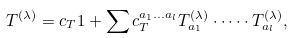<formula> <loc_0><loc_0><loc_500><loc_500>T ^ { ( \lambda ) } = c _ { T } { 1 } + \sum c _ { T } ^ { a _ { 1 } \dots a _ { l } } T ^ { ( \lambda ) } _ { a _ { 1 } } \cdot \dots \cdot T ^ { ( \lambda ) } _ { a _ { l } } ,</formula> 